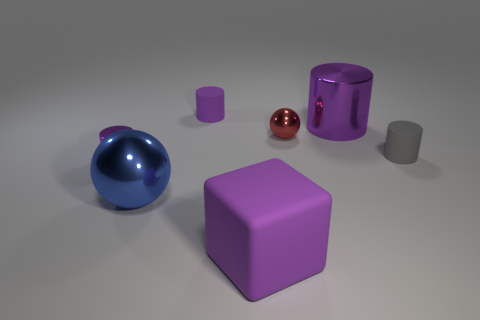What number of other things are there of the same material as the tiny gray thing
Your response must be concise. 2. There is a thing that is both on the right side of the red ball and behind the small gray matte cylinder; what is its shape?
Your response must be concise. Cylinder. Does the large rubber object have the same color as the rubber cylinder that is behind the red ball?
Provide a short and direct response. Yes. There is a matte thing that is behind the gray matte cylinder; is it the same size as the red shiny object?
Provide a short and direct response. Yes. What is the material of the tiny gray thing that is the same shape as the small purple shiny thing?
Make the answer very short. Rubber. Does the big blue object have the same shape as the red shiny thing?
Offer a terse response. Yes. What number of large shiny things are behind the small red metallic ball behind the large purple cube?
Provide a succinct answer. 1. What shape is the gray thing that is the same material as the cube?
Your answer should be very brief. Cylinder. How many brown things are either metallic objects or tiny metal cylinders?
Ensure brevity in your answer.  0. Are there any balls that are in front of the tiny purple cylinder in front of the rubber object that is left of the large matte cube?
Provide a succinct answer. Yes. 